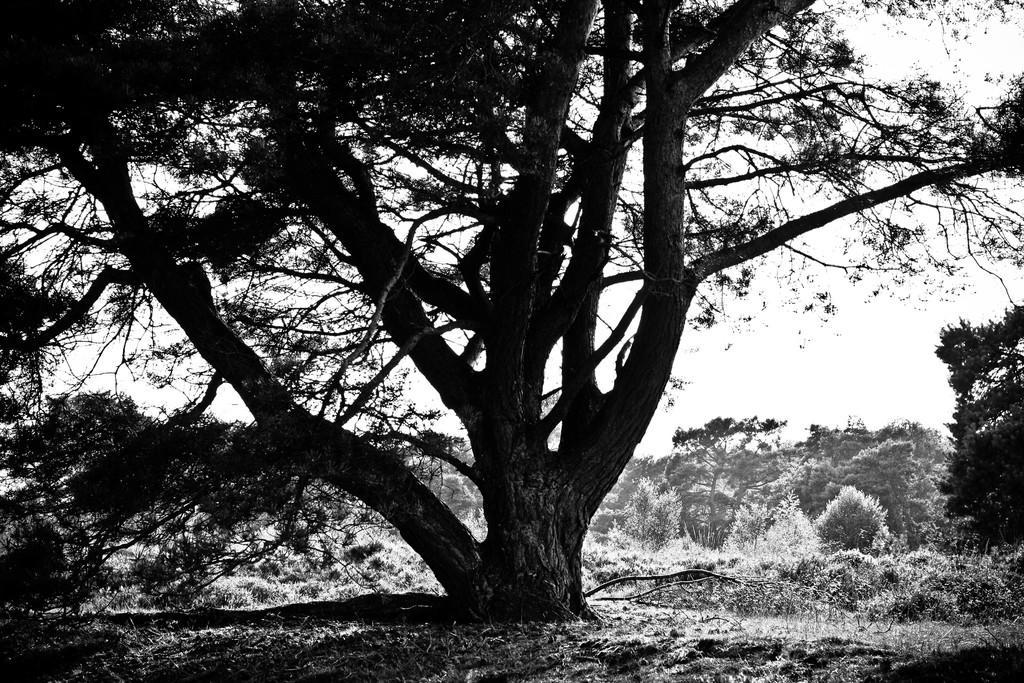How would you summarize this image in a sentence or two? In this black and white image there are trees, grass and in the background there is the sky. 